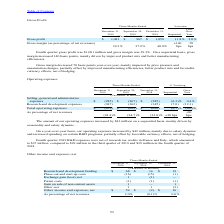According to Stmicroelectronics's financial document, What led to the increase in the gross margin on a sequential basis? mainly driven by improved product mix and better manufacturing efficiencies.. The document states: "al basis, gross margin increased 140 basis points, mainly driven by improved product mix and better manufacturing efficiencies...." Also, How much did the gross margin increase on a sequential basis According to the financial document, 140 basis points. The relevant text states: "3%. On a sequential basis, gross margin increased 140 basis points, mainly driven by improved product mix and better manufacturing efficiencies...." Also, What led to the decrease in the gross margin year-over-year mainly impacted by price pressure and unsaturation charges, partially offset by improved manufacturing efficiencies, better product mix and favorable currency effects, net of hedging.. The document states: "s margin decreased 70 basis points year-over-year, mainly impacted by price pressure and unsaturation charges, partially offset by improved manufactur..." Also, can you calculate: What is the average Gross profit for the period December 31, 2019 and 2018? To answer this question, I need to perform calculations using the financial data. The calculation is: (1,081+1,059) / 2, which equals 1070 (in millions). This is based on the information: "Gross profit $ 1,081 $ 967 $ 1,059 11.8% 2.0% Gross profit $ 1,081 $ 967 $ 1,059 11.8% 2.0%..." The key data points involved are: 1,059, 1,081. Also, can you calculate: What is the average Gross margin (as percentage of net revenues) for the period December 31, 2019 and 2018? To answer this question, I need to perform calculations using the financial data. The calculation is: (39.3+40.0) / 2, which equals 39.65 (percentage). This is based on the information: "39.3% 37.9% 40.0% 39.3% 37.9% 40.0%..." The key data points involved are: 39.3, 40.0. Also, can you calculate: What is the increase/ (decrease) in Gross profit from the period December 31, 2018 to 2019? Based on the calculation: 1,081-1,059, the result is 22 (in millions). This is based on the information: "Gross profit $ 1,081 $ 967 $ 1,059 11.8% 2.0% Gross profit $ 1,081 $ 967 $ 1,059 11.8% 2.0%..." The key data points involved are: 1,059, 1,081. 